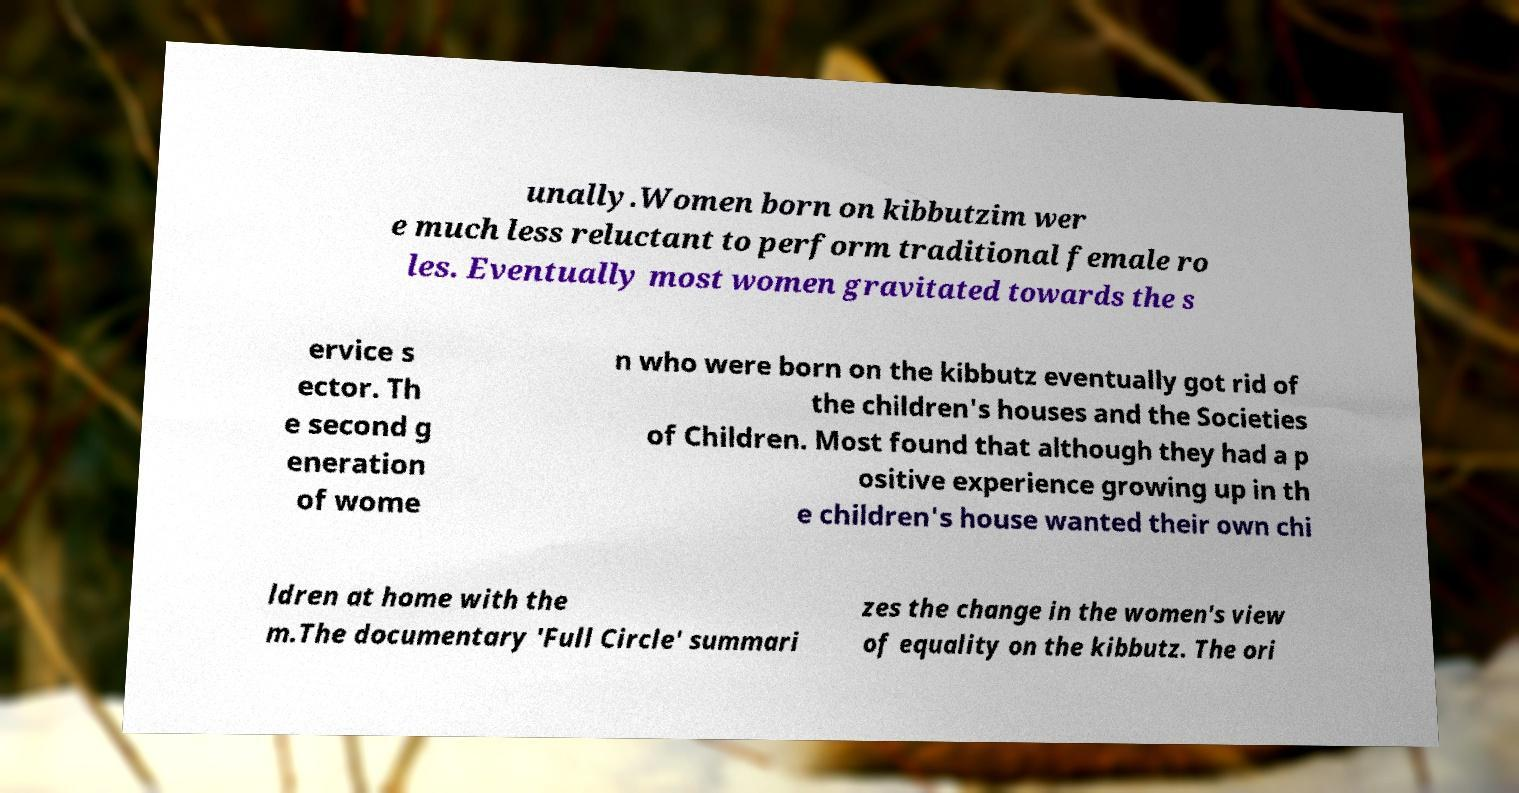I need the written content from this picture converted into text. Can you do that? unally.Women born on kibbutzim wer e much less reluctant to perform traditional female ro les. Eventually most women gravitated towards the s ervice s ector. Th e second g eneration of wome n who were born on the kibbutz eventually got rid of the children's houses and the Societies of Children. Most found that although they had a p ositive experience growing up in th e children's house wanted their own chi ldren at home with the m.The documentary 'Full Circle' summari zes the change in the women's view of equality on the kibbutz. The ori 